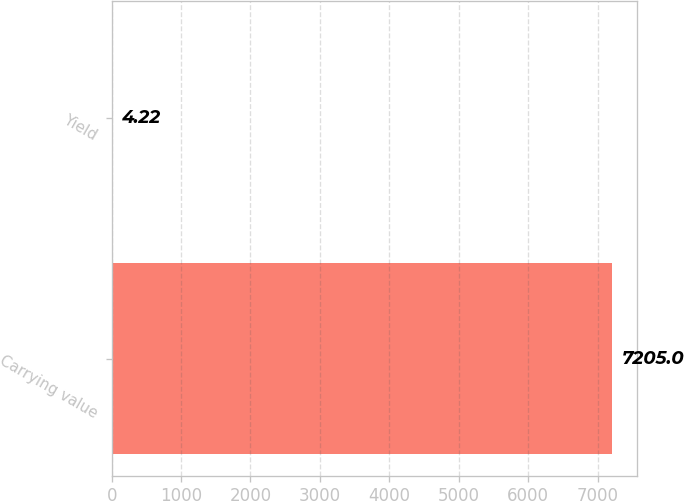Convert chart. <chart><loc_0><loc_0><loc_500><loc_500><bar_chart><fcel>Carrying value<fcel>Yield<nl><fcel>7205<fcel>4.22<nl></chart> 